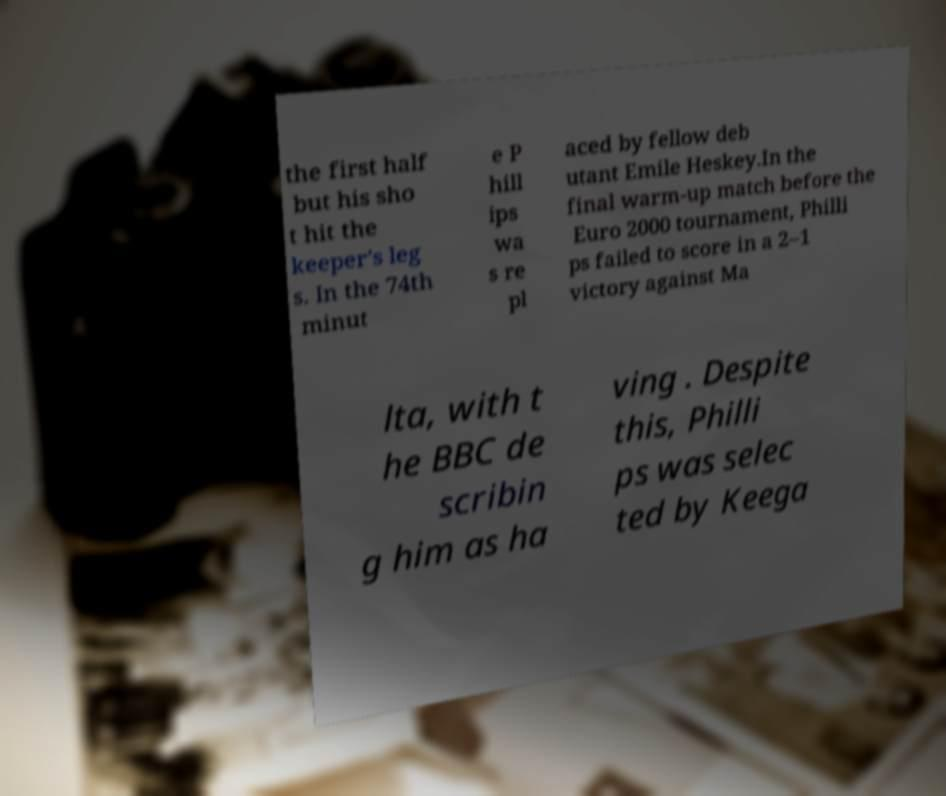Could you assist in decoding the text presented in this image and type it out clearly? the first half but his sho t hit the keeper's leg s. In the 74th minut e P hill ips wa s re pl aced by fellow deb utant Emile Heskey.In the final warm-up match before the Euro 2000 tournament, Philli ps failed to score in a 2–1 victory against Ma lta, with t he BBC de scribin g him as ha ving . Despite this, Philli ps was selec ted by Keega 